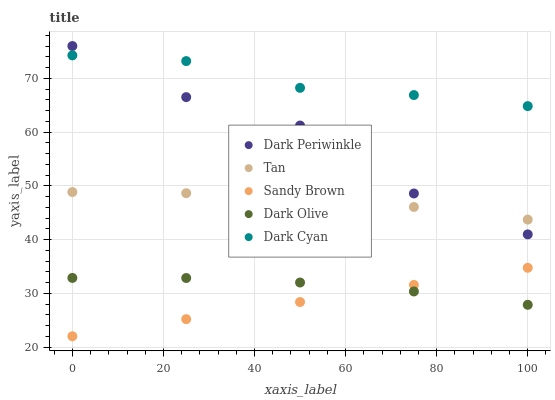Does Sandy Brown have the minimum area under the curve?
Answer yes or no. Yes. Does Dark Cyan have the maximum area under the curve?
Answer yes or no. Yes. Does Tan have the minimum area under the curve?
Answer yes or no. No. Does Tan have the maximum area under the curve?
Answer yes or no. No. Is Sandy Brown the smoothest?
Answer yes or no. Yes. Is Dark Periwinkle the roughest?
Answer yes or no. Yes. Is Tan the smoothest?
Answer yes or no. No. Is Tan the roughest?
Answer yes or no. No. Does Sandy Brown have the lowest value?
Answer yes or no. Yes. Does Tan have the lowest value?
Answer yes or no. No. Does Dark Periwinkle have the highest value?
Answer yes or no. Yes. Does Tan have the highest value?
Answer yes or no. No. Is Dark Olive less than Dark Periwinkle?
Answer yes or no. Yes. Is Dark Cyan greater than Dark Olive?
Answer yes or no. Yes. Does Dark Periwinkle intersect Tan?
Answer yes or no. Yes. Is Dark Periwinkle less than Tan?
Answer yes or no. No. Is Dark Periwinkle greater than Tan?
Answer yes or no. No. Does Dark Olive intersect Dark Periwinkle?
Answer yes or no. No. 